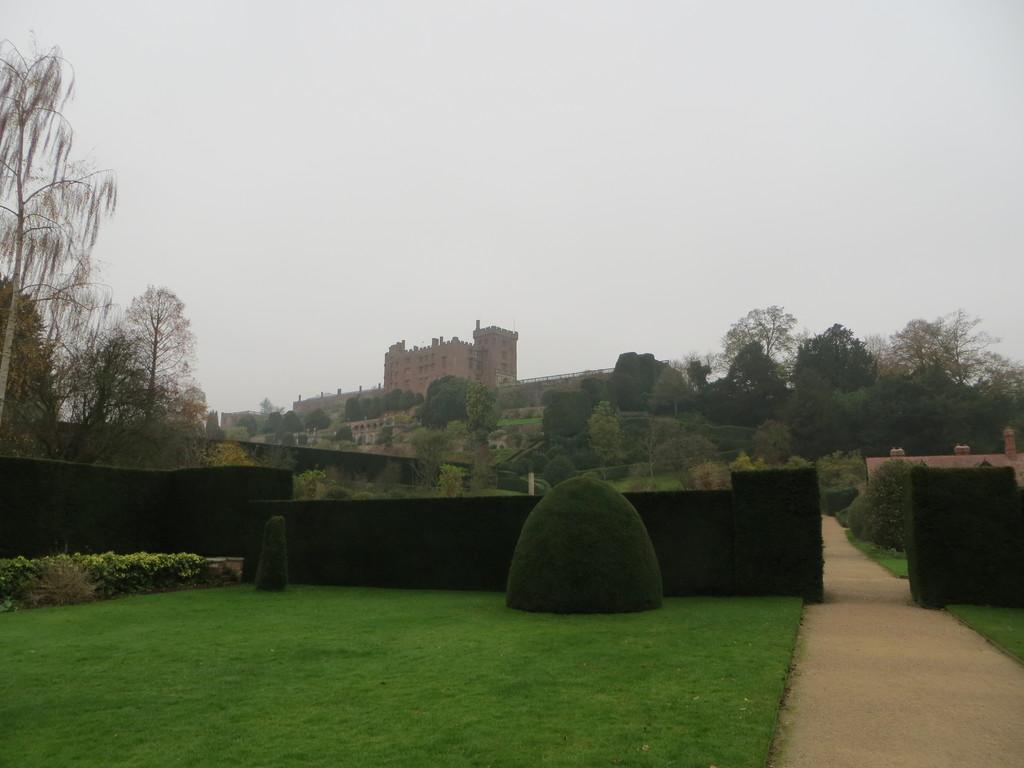What is the main structure in the center of the image? There is a fort in the center of the image. What type of vegetation is present at the bottom of the image? Bushes, hedges, and trees are visible at the bottom of the image. What is visible at the top of the image? The sky is visible at the top of the image. How many girls can be seen playing in the clouds in the image? There are no girls or clouds present in the image. What is the altitude of the fort in the image? The altitude of the fort cannot be determined from the image alone. 